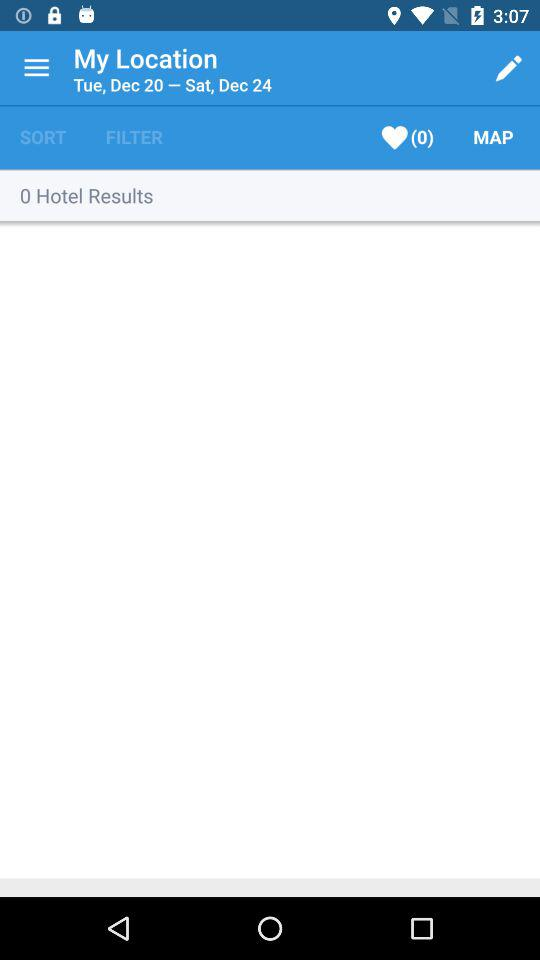What is the check out date? The check out date is Saturday, December 24. 